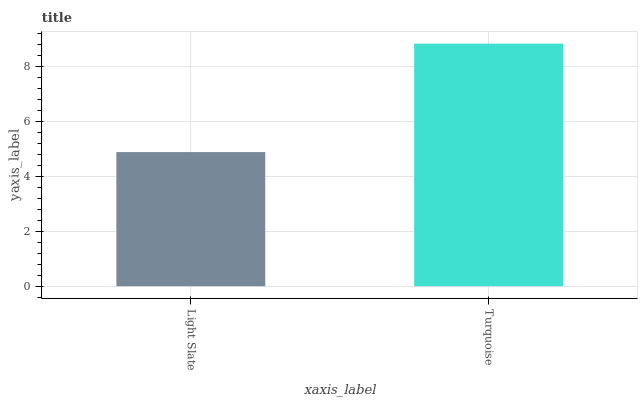Is Light Slate the minimum?
Answer yes or no. Yes. Is Turquoise the maximum?
Answer yes or no. Yes. Is Turquoise the minimum?
Answer yes or no. No. Is Turquoise greater than Light Slate?
Answer yes or no. Yes. Is Light Slate less than Turquoise?
Answer yes or no. Yes. Is Light Slate greater than Turquoise?
Answer yes or no. No. Is Turquoise less than Light Slate?
Answer yes or no. No. Is Turquoise the high median?
Answer yes or no. Yes. Is Light Slate the low median?
Answer yes or no. Yes. Is Light Slate the high median?
Answer yes or no. No. Is Turquoise the low median?
Answer yes or no. No. 